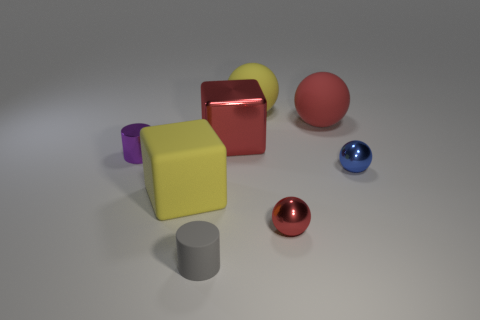There is a tiny ball that is the same color as the large metallic cube; what is it made of?
Offer a very short reply. Metal. Is the shape of the tiny gray object the same as the big yellow rubber object that is behind the small blue sphere?
Your answer should be compact. No. There is a big red thing that is made of the same material as the tiny purple object; what shape is it?
Make the answer very short. Cube. Are there more gray objects that are behind the red shiny block than cylinders to the right of the red rubber sphere?
Your response must be concise. No. How many objects are either purple metal cylinders or big cyan rubber cylinders?
Offer a terse response. 1. What number of other things are there of the same color as the big rubber cube?
Provide a succinct answer. 1. There is a red matte object that is the same size as the metal cube; what shape is it?
Offer a terse response. Sphere. The big matte thing in front of the large shiny cube is what color?
Your answer should be compact. Yellow. How many objects are either large red metal objects in front of the large yellow sphere or small metallic balls that are on the right side of the tiny red sphere?
Offer a terse response. 2. Is the shiny cylinder the same size as the blue thing?
Provide a succinct answer. Yes. 